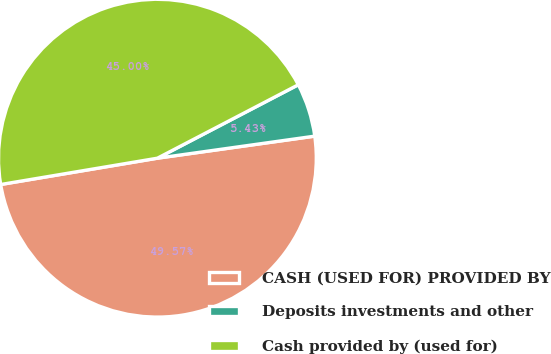Convert chart to OTSL. <chart><loc_0><loc_0><loc_500><loc_500><pie_chart><fcel>CASH (USED FOR) PROVIDED BY<fcel>Deposits investments and other<fcel>Cash provided by (used for)<nl><fcel>49.57%<fcel>5.43%<fcel>45.0%<nl></chart> 